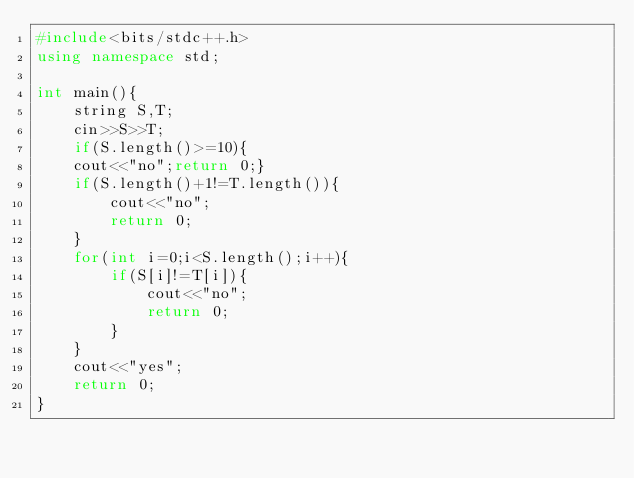<code> <loc_0><loc_0><loc_500><loc_500><_C++_>#include<bits/stdc++.h>
using namespace std;

int main(){
	string S,T;
	cin>>S>>T;
	if(S.length()>=10){
	cout<<"no";return 0;}
	if(S.length()+1!=T.length()){
		cout<<"no";
		return 0;
	}
	for(int i=0;i<S.length();i++){
		if(S[i]!=T[i]){
			cout<<"no";
			return 0;
		}
	}
	cout<<"yes";
	return 0;
}
</code> 